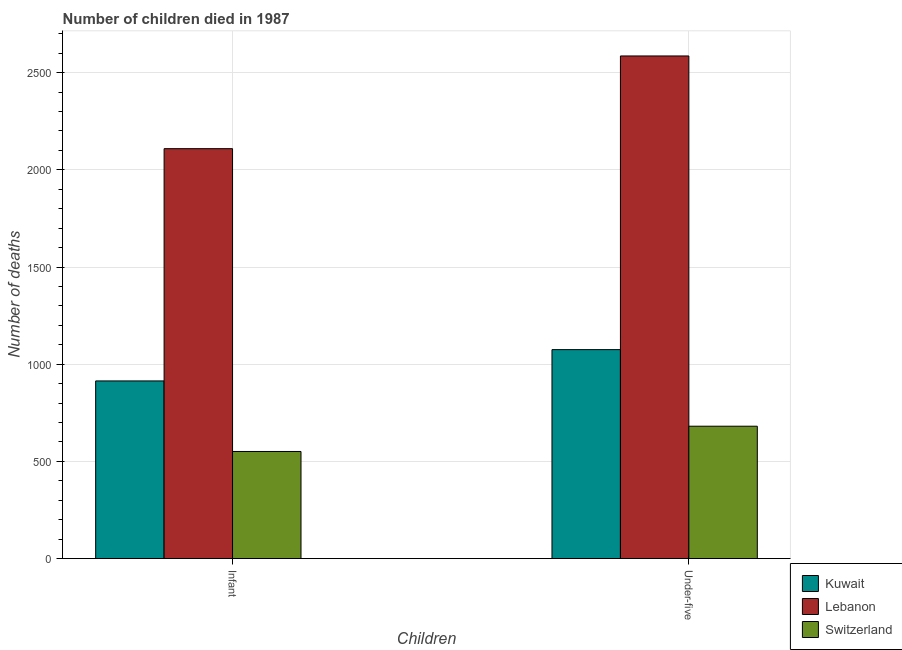How many different coloured bars are there?
Provide a short and direct response. 3. Are the number of bars per tick equal to the number of legend labels?
Give a very brief answer. Yes. How many bars are there on the 2nd tick from the right?
Make the answer very short. 3. What is the label of the 1st group of bars from the left?
Provide a short and direct response. Infant. What is the number of under-five deaths in Switzerland?
Offer a very short reply. 681. Across all countries, what is the maximum number of under-five deaths?
Your response must be concise. 2586. Across all countries, what is the minimum number of infant deaths?
Ensure brevity in your answer.  551. In which country was the number of infant deaths maximum?
Your response must be concise. Lebanon. In which country was the number of infant deaths minimum?
Provide a succinct answer. Switzerland. What is the total number of infant deaths in the graph?
Keep it short and to the point. 3574. What is the difference between the number of under-five deaths in Switzerland and that in Kuwait?
Ensure brevity in your answer.  -394. What is the difference between the number of infant deaths in Lebanon and the number of under-five deaths in Switzerland?
Ensure brevity in your answer.  1428. What is the average number of infant deaths per country?
Provide a short and direct response. 1191.33. What is the difference between the number of under-five deaths and number of infant deaths in Lebanon?
Give a very brief answer. 477. In how many countries, is the number of infant deaths greater than 1400 ?
Your response must be concise. 1. What is the ratio of the number of infant deaths in Lebanon to that in Kuwait?
Make the answer very short. 2.31. In how many countries, is the number of under-five deaths greater than the average number of under-five deaths taken over all countries?
Your answer should be compact. 1. What does the 1st bar from the left in Infant represents?
Provide a succinct answer. Kuwait. What does the 1st bar from the right in Under-five represents?
Offer a terse response. Switzerland. Are all the bars in the graph horizontal?
Keep it short and to the point. No. What is the difference between two consecutive major ticks on the Y-axis?
Your answer should be very brief. 500. Does the graph contain any zero values?
Offer a terse response. No. Does the graph contain grids?
Your answer should be compact. Yes. How are the legend labels stacked?
Your answer should be very brief. Vertical. What is the title of the graph?
Ensure brevity in your answer.  Number of children died in 1987. What is the label or title of the X-axis?
Provide a succinct answer. Children. What is the label or title of the Y-axis?
Your answer should be very brief. Number of deaths. What is the Number of deaths of Kuwait in Infant?
Your response must be concise. 914. What is the Number of deaths of Lebanon in Infant?
Provide a short and direct response. 2109. What is the Number of deaths of Switzerland in Infant?
Make the answer very short. 551. What is the Number of deaths in Kuwait in Under-five?
Keep it short and to the point. 1075. What is the Number of deaths in Lebanon in Under-five?
Your answer should be compact. 2586. What is the Number of deaths in Switzerland in Under-five?
Give a very brief answer. 681. Across all Children, what is the maximum Number of deaths of Kuwait?
Keep it short and to the point. 1075. Across all Children, what is the maximum Number of deaths in Lebanon?
Your answer should be compact. 2586. Across all Children, what is the maximum Number of deaths of Switzerland?
Offer a very short reply. 681. Across all Children, what is the minimum Number of deaths of Kuwait?
Give a very brief answer. 914. Across all Children, what is the minimum Number of deaths in Lebanon?
Provide a succinct answer. 2109. Across all Children, what is the minimum Number of deaths in Switzerland?
Provide a short and direct response. 551. What is the total Number of deaths in Kuwait in the graph?
Make the answer very short. 1989. What is the total Number of deaths in Lebanon in the graph?
Your answer should be very brief. 4695. What is the total Number of deaths in Switzerland in the graph?
Offer a terse response. 1232. What is the difference between the Number of deaths of Kuwait in Infant and that in Under-five?
Offer a very short reply. -161. What is the difference between the Number of deaths of Lebanon in Infant and that in Under-five?
Provide a short and direct response. -477. What is the difference between the Number of deaths in Switzerland in Infant and that in Under-five?
Ensure brevity in your answer.  -130. What is the difference between the Number of deaths in Kuwait in Infant and the Number of deaths in Lebanon in Under-five?
Your answer should be compact. -1672. What is the difference between the Number of deaths in Kuwait in Infant and the Number of deaths in Switzerland in Under-five?
Your answer should be very brief. 233. What is the difference between the Number of deaths in Lebanon in Infant and the Number of deaths in Switzerland in Under-five?
Ensure brevity in your answer.  1428. What is the average Number of deaths of Kuwait per Children?
Provide a short and direct response. 994.5. What is the average Number of deaths of Lebanon per Children?
Your response must be concise. 2347.5. What is the average Number of deaths of Switzerland per Children?
Your answer should be compact. 616. What is the difference between the Number of deaths in Kuwait and Number of deaths in Lebanon in Infant?
Offer a very short reply. -1195. What is the difference between the Number of deaths of Kuwait and Number of deaths of Switzerland in Infant?
Your response must be concise. 363. What is the difference between the Number of deaths in Lebanon and Number of deaths in Switzerland in Infant?
Your answer should be very brief. 1558. What is the difference between the Number of deaths in Kuwait and Number of deaths in Lebanon in Under-five?
Your answer should be compact. -1511. What is the difference between the Number of deaths of Kuwait and Number of deaths of Switzerland in Under-five?
Make the answer very short. 394. What is the difference between the Number of deaths of Lebanon and Number of deaths of Switzerland in Under-five?
Your response must be concise. 1905. What is the ratio of the Number of deaths in Kuwait in Infant to that in Under-five?
Provide a succinct answer. 0.85. What is the ratio of the Number of deaths in Lebanon in Infant to that in Under-five?
Keep it short and to the point. 0.82. What is the ratio of the Number of deaths in Switzerland in Infant to that in Under-five?
Ensure brevity in your answer.  0.81. What is the difference between the highest and the second highest Number of deaths in Kuwait?
Offer a terse response. 161. What is the difference between the highest and the second highest Number of deaths of Lebanon?
Ensure brevity in your answer.  477. What is the difference between the highest and the second highest Number of deaths in Switzerland?
Give a very brief answer. 130. What is the difference between the highest and the lowest Number of deaths of Kuwait?
Provide a succinct answer. 161. What is the difference between the highest and the lowest Number of deaths of Lebanon?
Provide a succinct answer. 477. What is the difference between the highest and the lowest Number of deaths in Switzerland?
Your answer should be very brief. 130. 